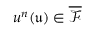Convert formula to latex. <formula><loc_0><loc_0><loc_500><loc_500>u ^ { n } ( \mathfrak { u } ) \in \overline { { \mathcal { F } } }</formula> 